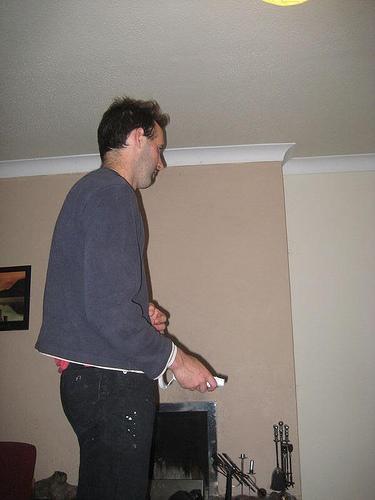How many giraffes are leaning down to drink?
Give a very brief answer. 0. 